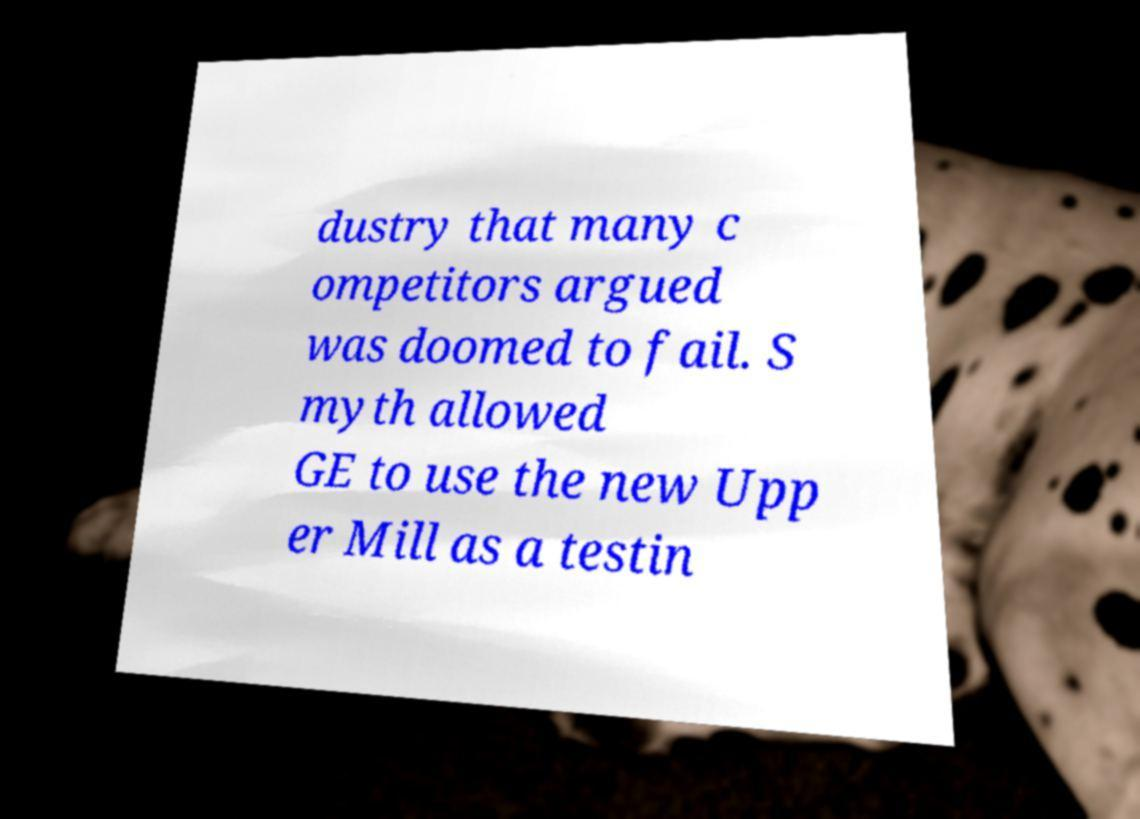I need the written content from this picture converted into text. Can you do that? dustry that many c ompetitors argued was doomed to fail. S myth allowed GE to use the new Upp er Mill as a testin 